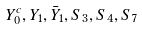<formula> <loc_0><loc_0><loc_500><loc_500>Y _ { 0 } ^ { c } , Y _ { 1 } , \bar { Y } _ { 1 } , S _ { 3 } , S _ { 4 } , S _ { 7 }</formula> 